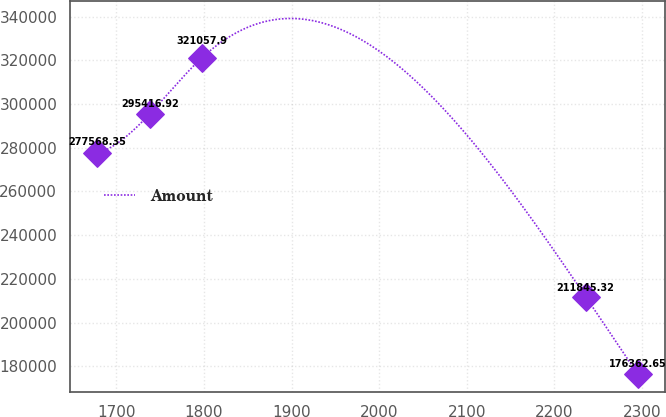Convert chart to OTSL. <chart><loc_0><loc_0><loc_500><loc_500><line_chart><ecel><fcel>Amount<nl><fcel>1678.55<fcel>277568<nl><fcel>1738.1<fcel>295417<nl><fcel>1797.65<fcel>321058<nl><fcel>2235.68<fcel>211845<nl><fcel>2295.23<fcel>176363<nl></chart> 